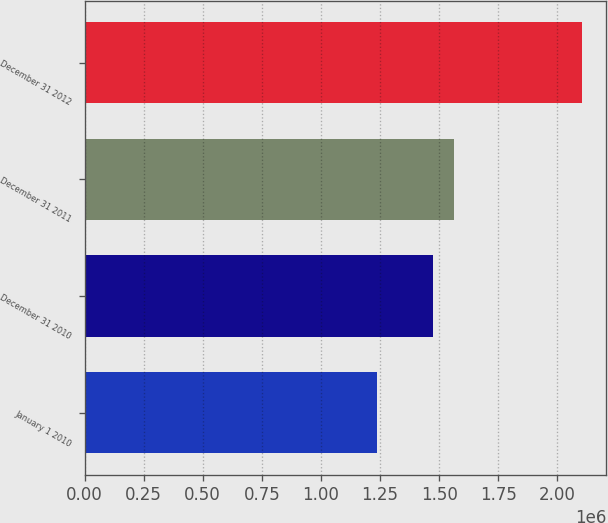Convert chart to OTSL. <chart><loc_0><loc_0><loc_500><loc_500><bar_chart><fcel>January 1 2010<fcel>December 31 2010<fcel>December 31 2011<fcel>December 31 2012<nl><fcel>1.23827e+06<fcel>1.47222e+06<fcel>1.56116e+06<fcel>2.10284e+06<nl></chart> 